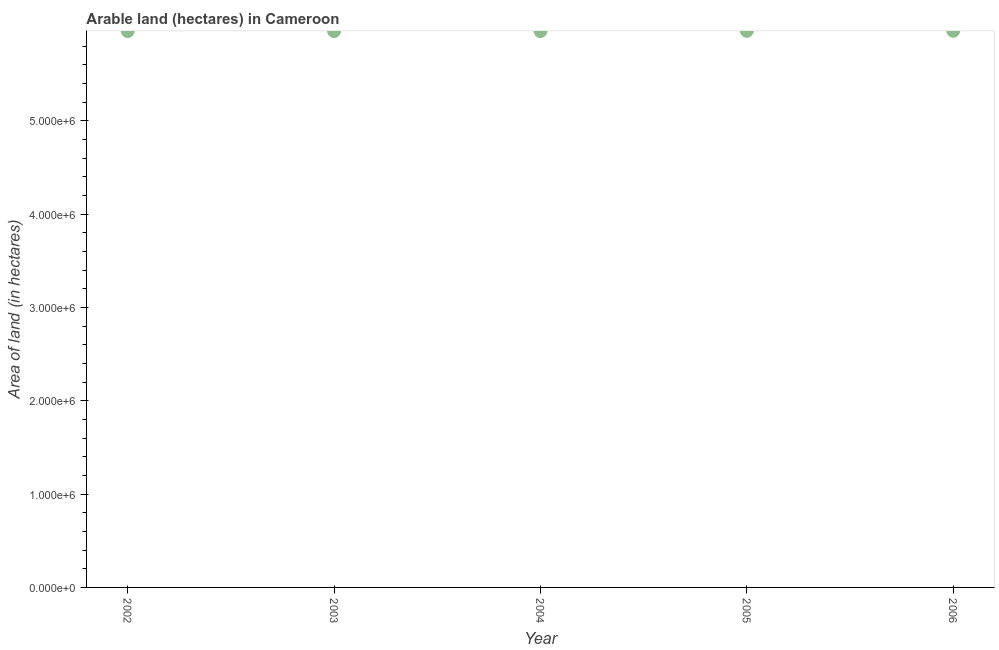What is the area of land in 2002?
Your response must be concise. 5.96e+06. Across all years, what is the maximum area of land?
Make the answer very short. 5.96e+06. Across all years, what is the minimum area of land?
Your answer should be very brief. 5.96e+06. In which year was the area of land minimum?
Keep it short and to the point. 2002. What is the sum of the area of land?
Ensure brevity in your answer.  2.98e+07. What is the difference between the area of land in 2002 and 2006?
Make the answer very short. -3000. What is the average area of land per year?
Your answer should be compact. 5.96e+06. What is the median area of land?
Your response must be concise. 5.96e+06. In how many years, is the area of land greater than 2400000 hectares?
Provide a short and direct response. 5. What is the ratio of the area of land in 2003 to that in 2005?
Your answer should be very brief. 1. Is the difference between the area of land in 2002 and 2004 greater than the difference between any two years?
Ensure brevity in your answer.  No. What is the difference between the highest and the second highest area of land?
Provide a succinct answer. 0. What is the difference between the highest and the lowest area of land?
Give a very brief answer. 3000. In how many years, is the area of land greater than the average area of land taken over all years?
Keep it short and to the point. 2. Does the area of land monotonically increase over the years?
Give a very brief answer. No. How many dotlines are there?
Ensure brevity in your answer.  1. What is the difference between two consecutive major ticks on the Y-axis?
Offer a very short reply. 1.00e+06. Does the graph contain grids?
Provide a short and direct response. No. What is the title of the graph?
Offer a terse response. Arable land (hectares) in Cameroon. What is the label or title of the X-axis?
Provide a short and direct response. Year. What is the label or title of the Y-axis?
Your answer should be compact. Area of land (in hectares). What is the Area of land (in hectares) in 2002?
Make the answer very short. 5.96e+06. What is the Area of land (in hectares) in 2003?
Your answer should be very brief. 5.96e+06. What is the Area of land (in hectares) in 2004?
Make the answer very short. 5.96e+06. What is the Area of land (in hectares) in 2005?
Your answer should be compact. 5.96e+06. What is the Area of land (in hectares) in 2006?
Offer a terse response. 5.96e+06. What is the difference between the Area of land (in hectares) in 2002 and 2003?
Give a very brief answer. 0. What is the difference between the Area of land (in hectares) in 2002 and 2005?
Provide a short and direct response. -3000. What is the difference between the Area of land (in hectares) in 2002 and 2006?
Offer a very short reply. -3000. What is the difference between the Area of land (in hectares) in 2003 and 2005?
Your answer should be very brief. -3000. What is the difference between the Area of land (in hectares) in 2003 and 2006?
Your answer should be compact. -3000. What is the difference between the Area of land (in hectares) in 2004 and 2005?
Provide a succinct answer. -3000. What is the difference between the Area of land (in hectares) in 2004 and 2006?
Ensure brevity in your answer.  -3000. What is the difference between the Area of land (in hectares) in 2005 and 2006?
Make the answer very short. 0. What is the ratio of the Area of land (in hectares) in 2002 to that in 2005?
Give a very brief answer. 1. What is the ratio of the Area of land (in hectares) in 2002 to that in 2006?
Your answer should be compact. 1. What is the ratio of the Area of land (in hectares) in 2003 to that in 2004?
Your answer should be very brief. 1. What is the ratio of the Area of land (in hectares) in 2003 to that in 2006?
Your answer should be compact. 1. What is the ratio of the Area of land (in hectares) in 2004 to that in 2005?
Your answer should be very brief. 1. What is the ratio of the Area of land (in hectares) in 2004 to that in 2006?
Offer a terse response. 1. What is the ratio of the Area of land (in hectares) in 2005 to that in 2006?
Provide a short and direct response. 1. 